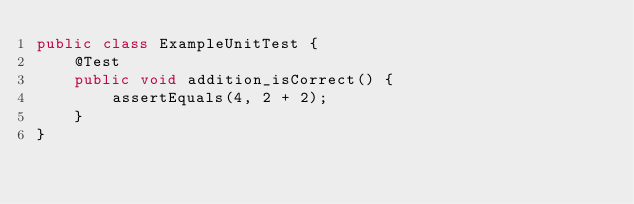<code> <loc_0><loc_0><loc_500><loc_500><_Java_>public class ExampleUnitTest {
    @Test
    public void addition_isCorrect() {
        assertEquals(4, 2 + 2);
    }
}</code> 